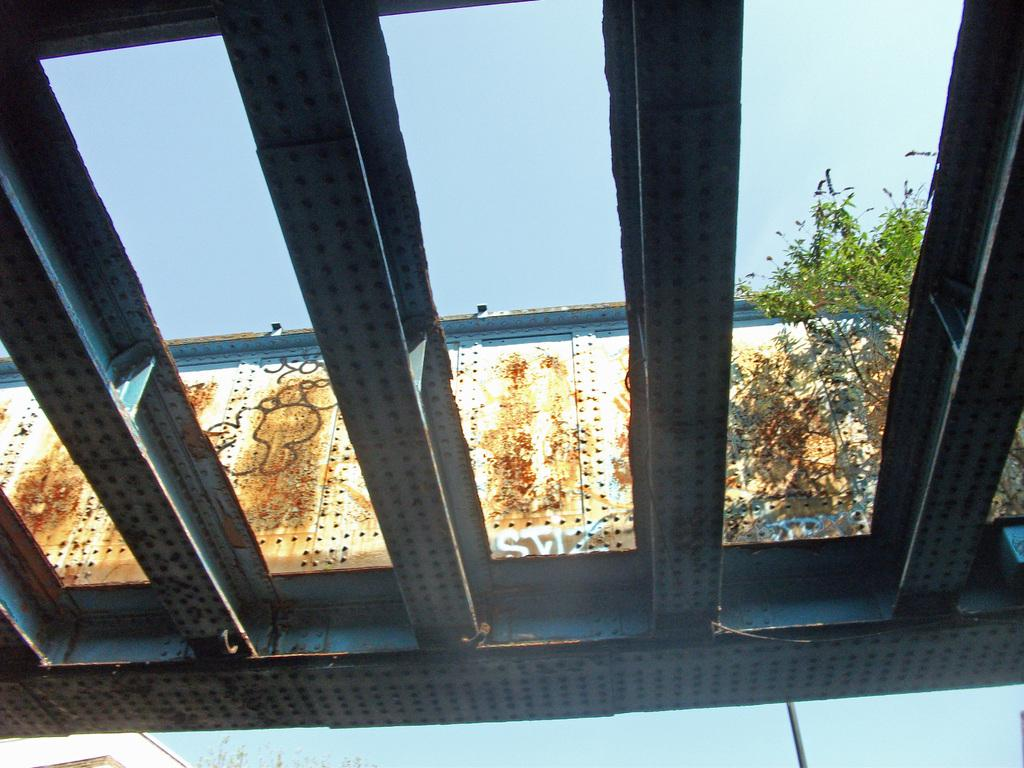What type of objects can be seen in the image? There are metal rods in the image. What natural element is present in the image? There is a tree in the image. What can be seen in the background of the image? There is a metal wall with rust in the background of the image, and the sky is also visible. How many ghosts are visible in the image? There are no ghosts present in the image. What type of power source is connected to the metal rods in the image? The image does not provide information about any power source connected to the metal rods. 